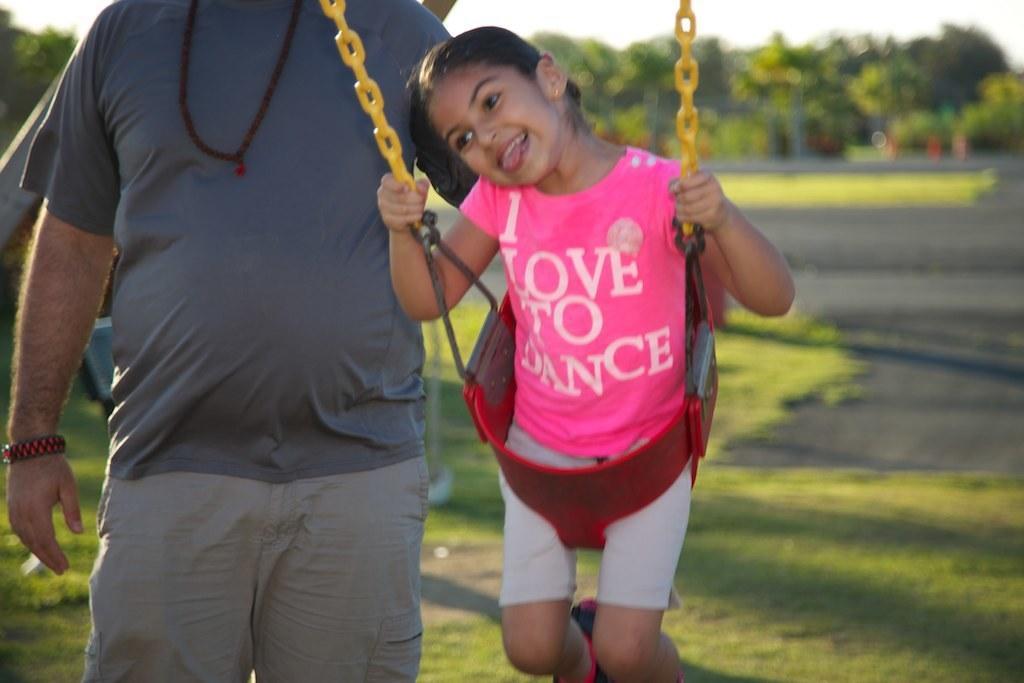Can you describe this image briefly? As we can see in the image there are two people, grass, trees and sky. The girl is wearing pink color dress and the man is wearing blue color t shirt. 